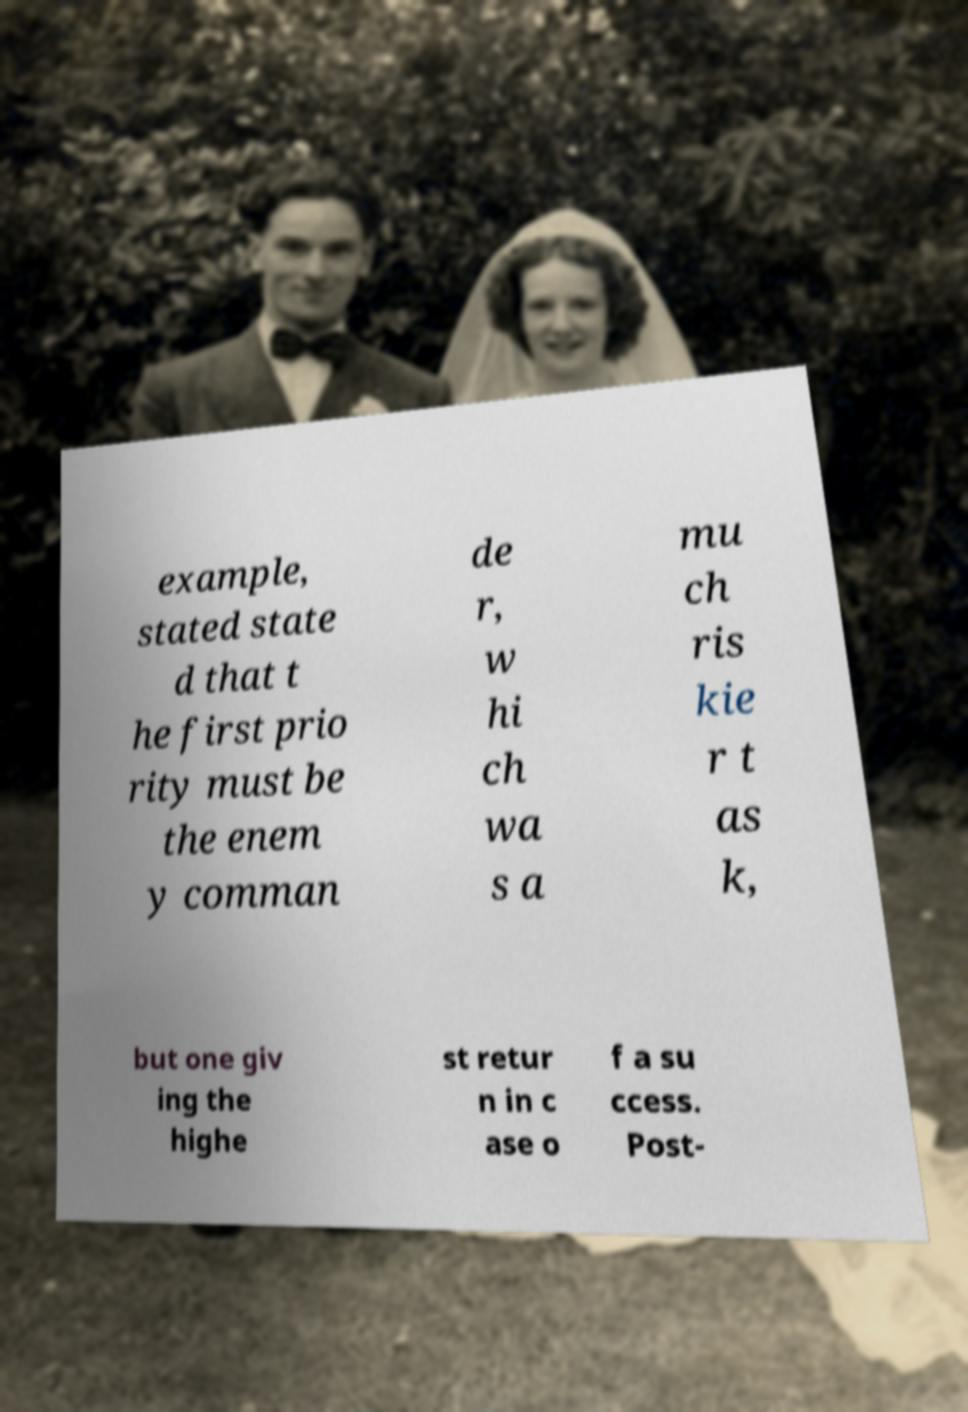For documentation purposes, I need the text within this image transcribed. Could you provide that? example, stated state d that t he first prio rity must be the enem y comman de r, w hi ch wa s a mu ch ris kie r t as k, but one giv ing the highe st retur n in c ase o f a su ccess. Post- 